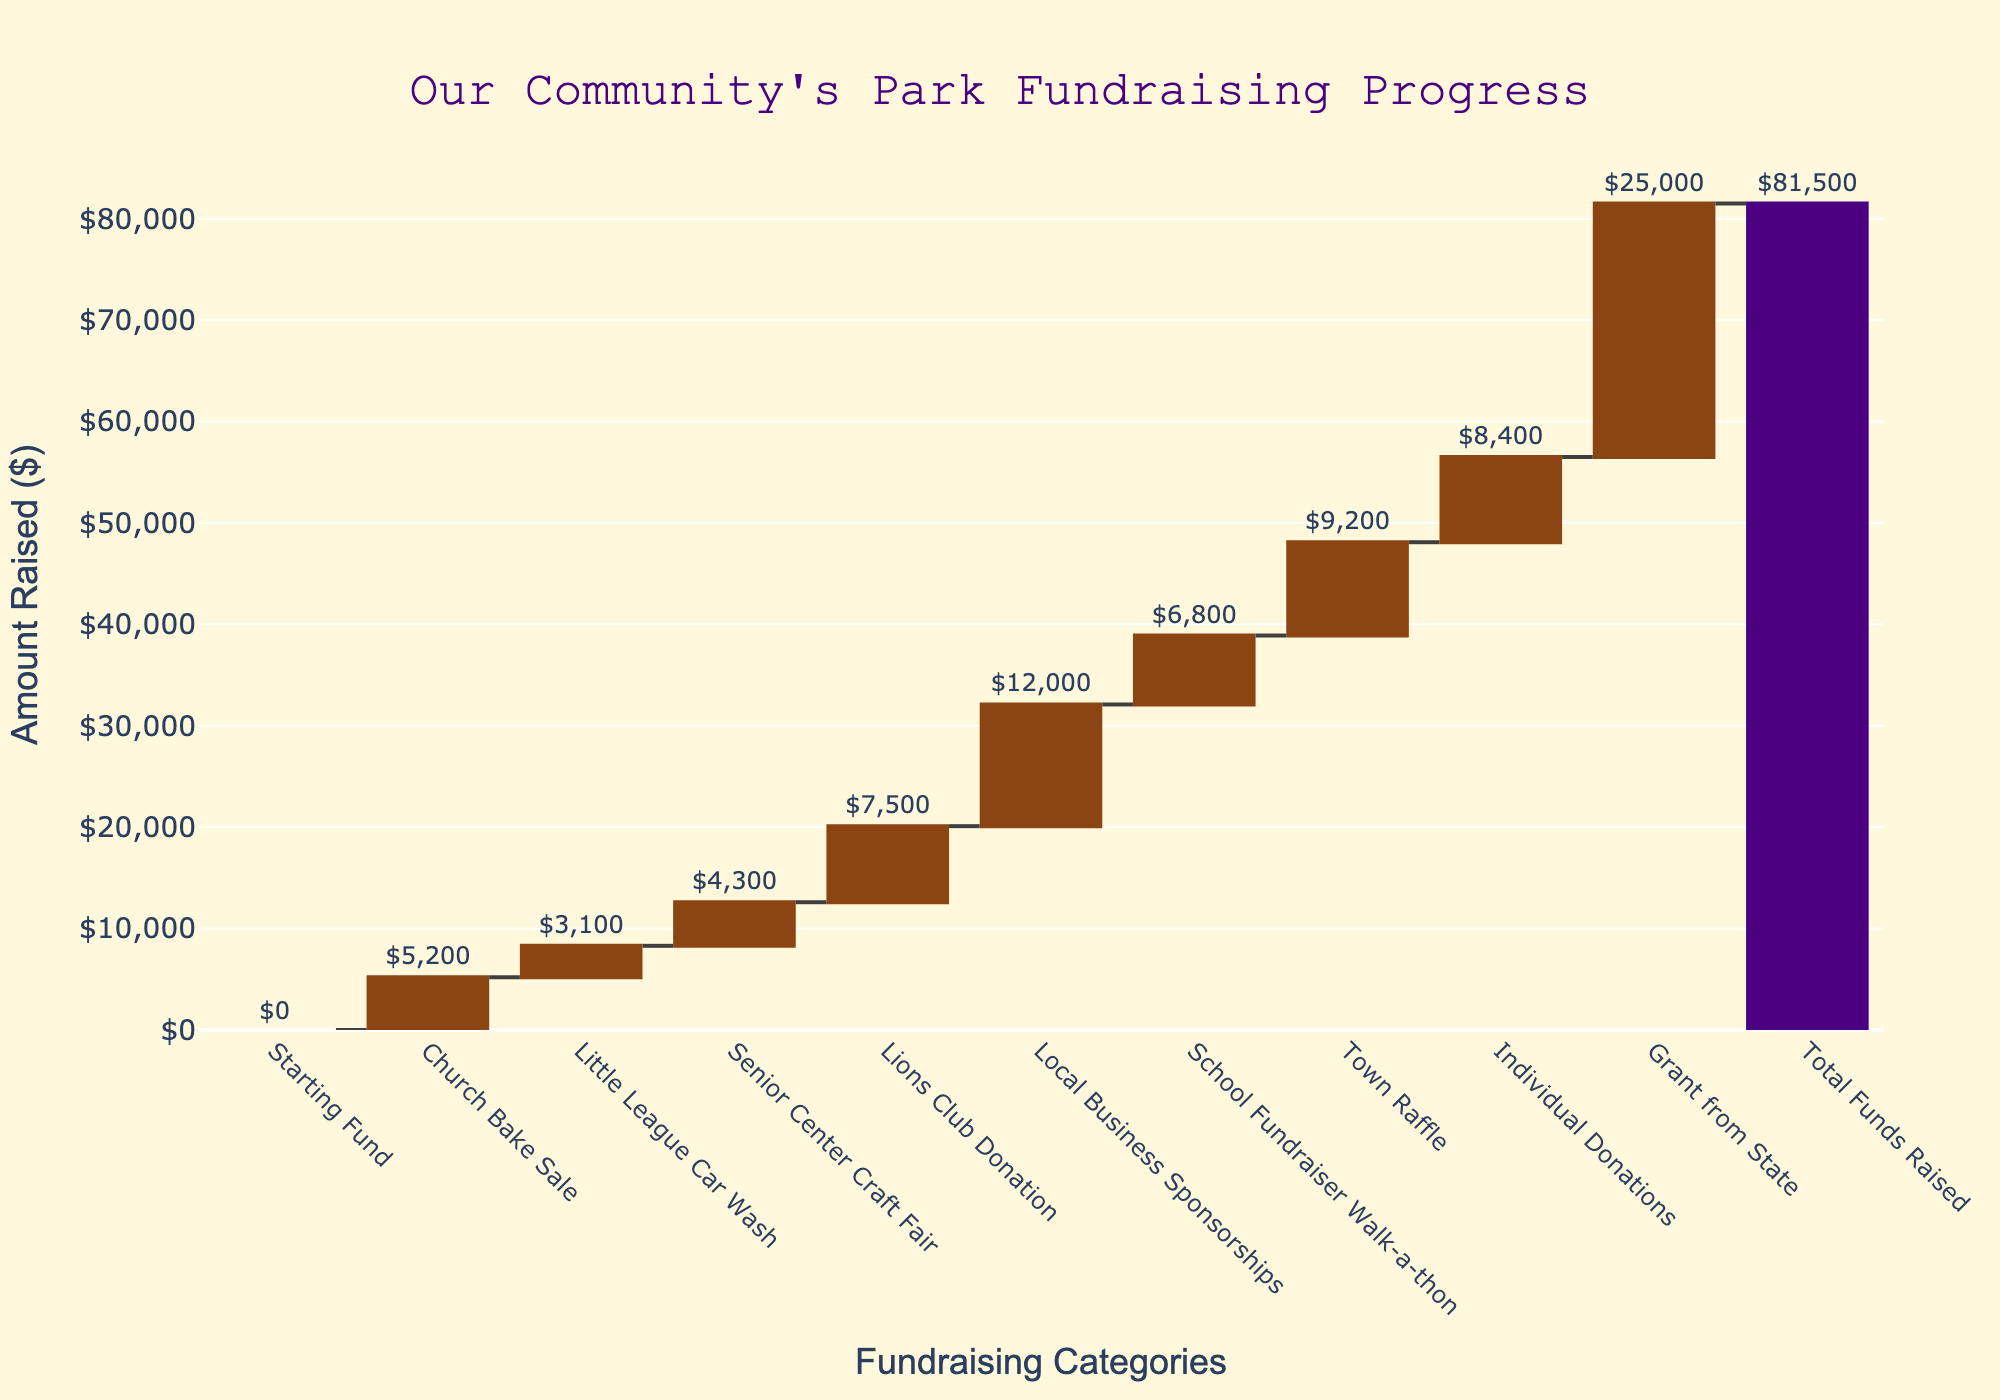How much money was raised by the Church Bake Sale? The first increment in the waterfall chart represents the Church Bake Sale, with the amount placed above the corresponding segment.
Answer: $5,200 Which fundraising event contributed the highest amount? By examining the waterfall chart, the largest segment before the total funds represents the Grant from State, indicated by its height and the labeled amount.
Answer: Grant from State What's the total amount raised by the Little League Car Wash and Senior Center Craft Fair combined? Locate these two events on the chart and sum their labeled amounts: $3,100 + $4,300.
Answer: $7,400 How does the contribution from Local Business Sponsorships compare to the Lions Club Donation? Compare the heights and labeled amounts of the bars for Local Business Sponsorships and Lions Club Donation: $12,000 vs $7,500.
Answer: Local Business Sponsorships contributed more What is the grand total amount raised for the new park according to the chart? The last segment of the waterfall chart, often highlighted differently such as in a contrasting color, represents the total funds raised.
Answer: $81,500 What would be the remaining total if Individual Donations were excluded? Subtract the Individual Donations amount from the total: $81,500 - $8,400.
Answer: $73,100 Which contribution category shows the smallest amount raised? Identify the smallest bar segment which is the Little League Car Wash, and read its labeled amount.
Answer: Little League Car Wash How much funding came from events involving community activities like raffles, walks, and sales? Sum the amounts from Church Bake Sale, Little League Car Wash, Senior Center Craft Fair, School Fundraiser Walk-a-thon, and Town Raffle: $5,200 + $3,100 + $4,300 + $6,800 + $9,200.
Answer: $28,600 What is the increase in funds from the Lions Club Donation to Local Business Sponsorships? Subtract the amount raised by the Lions Club Donation from that of Local Business Sponsorships: $12,000 - $7,500.
Answer: $4,500 Explain how the total amount raised is calculated in the waterfall chart. The chart shows incremental amounts adding up, starting at $0 from the initial event, each subsequent bar adds its amount to the cumulative total, with the last bar representing the final total funds raised.
Answer: Sum of incremental amounts 